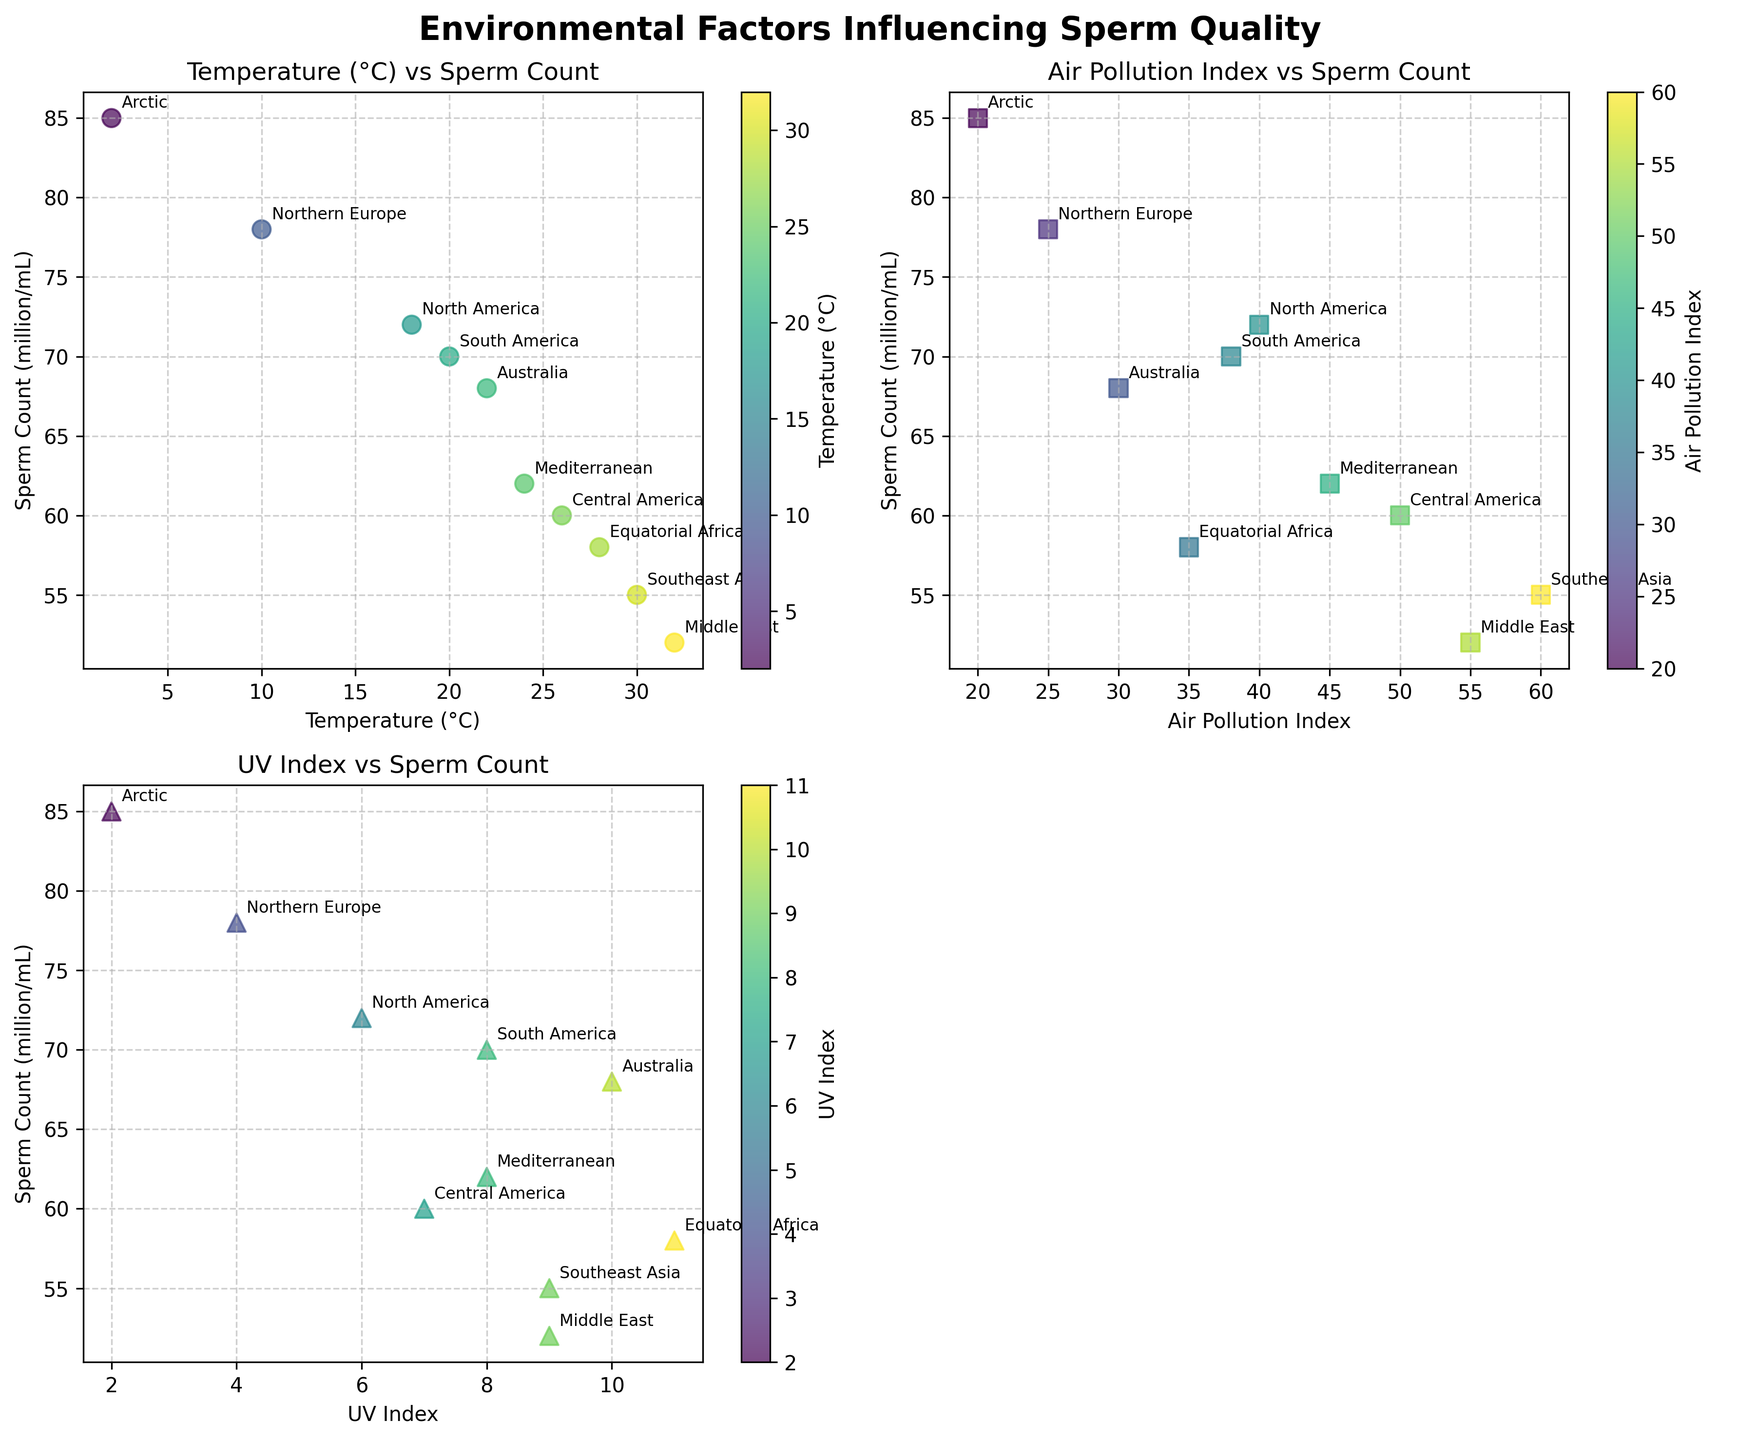What is the title of the figure? The title of the figure is usually found at the top of the plot, often highlighted in a larger or bold font. Here, it states the overall subject matter of the figure.
Answer: Environmental Factors Influencing Sperm Quality What are the x-axis and y-axis labels for the top-left scatter plot? The x-axis and y-axis labels describe the variables being plotted. For the top-left scatter plot, these labels are directly below and to the left of the plot, respectively.
Answer: Temperature (°C) and Sperm Count (million/mL) How many data points are there in total across all scatter plots? Each region is represented by a single data point in each scatter plot. There are 10 regions listed in the data.
Answer: 10 Which region has the highest sperm count and in which scatter plot is it located? The highest sperm count is seen by looking for the largest value on the y-axis across the scatter plots. This data point is labeled with its respective region.
Answer: Arctic in the top-left scatter plot Between Temperature (°C) and Sperm Count (million/mL), which region shows the largest decrease in sperm count? Comparing the data points of each region between the x-axis (Temperature) and y-axis (Sperm Count) reveals the region with the largest drop in sperm count.
Answer: Middle East Looking at the bottom-left scatter plot, which region has the lowest sperm count and what is its Air Pollution Index? The region with the lowest sperm count can be identified at the lowest point on the y-axis. The corresponding Air Pollution Index is given on the x-axis.
Answer: Middle East; 55 What is the average sperm count for regions with a UV Index higher than 8? Identify data points where the UV Index is greater than 8 and then calculate the average of their sperm counts.
Answer: 55 Which scatter plot plots Sperm Count against UV Index, and which region has the highest UV Index? The scatter plot with Sperm Count against UV Index will have UV Index on the x-axis. The point with the highest x-value represents the highest UV Index.
Answer: Bottom-right scatter plot (missing); Equatorial Africa Is there a noticeable trend in sperm count with increasing Air Pollution Index? To identify a trend, examine how sperm counts change as Air Pollution Index increases from left to right.
Answer: Sperm count tends to decrease with increasing Air Pollution Index Which two regions have the closest sperm counts, and what are their values? Compare the sperm counts across all regions in all scatter plots to find the two closest values.
Answer: Central America and Mediterranean; 60 and 62 